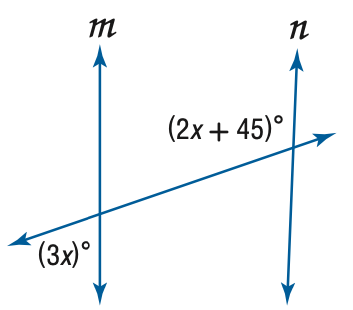Question: Find x so that m \parallel n.
Choices:
A. 9
B. 27
C. 45
D. 81
Answer with the letter. Answer: B 